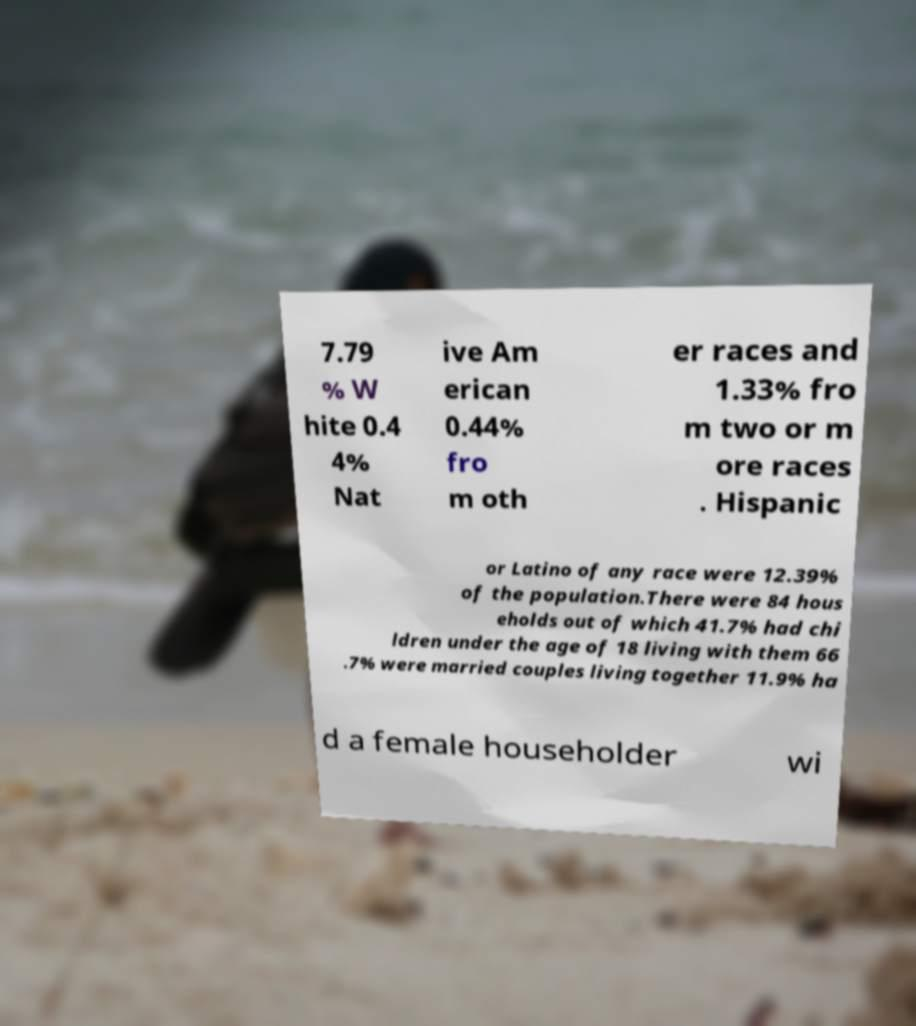There's text embedded in this image that I need extracted. Can you transcribe it verbatim? 7.79 % W hite 0.4 4% Nat ive Am erican 0.44% fro m oth er races and 1.33% fro m two or m ore races . Hispanic or Latino of any race were 12.39% of the population.There were 84 hous eholds out of which 41.7% had chi ldren under the age of 18 living with them 66 .7% were married couples living together 11.9% ha d a female householder wi 